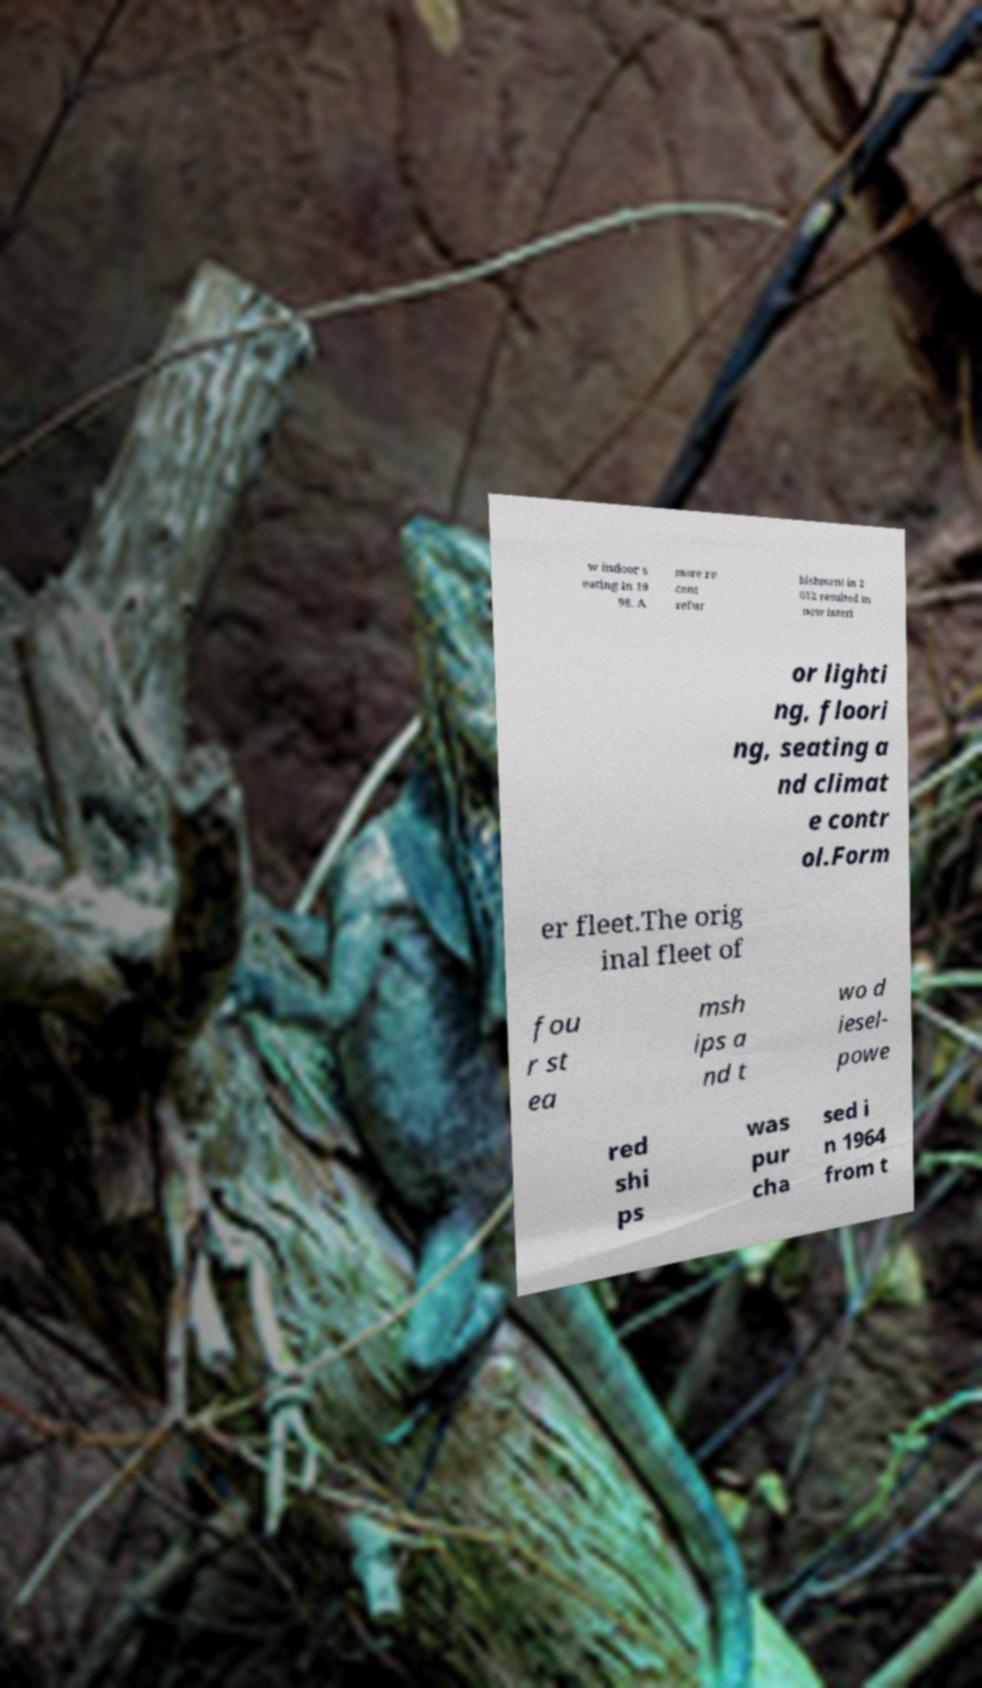For documentation purposes, I need the text within this image transcribed. Could you provide that? w indoor s eating in 19 98. A more re cent refur bishment in 2 012 resulted in new interi or lighti ng, floori ng, seating a nd climat e contr ol.Form er fleet.The orig inal fleet of fou r st ea msh ips a nd t wo d iesel- powe red shi ps was pur cha sed i n 1964 from t 